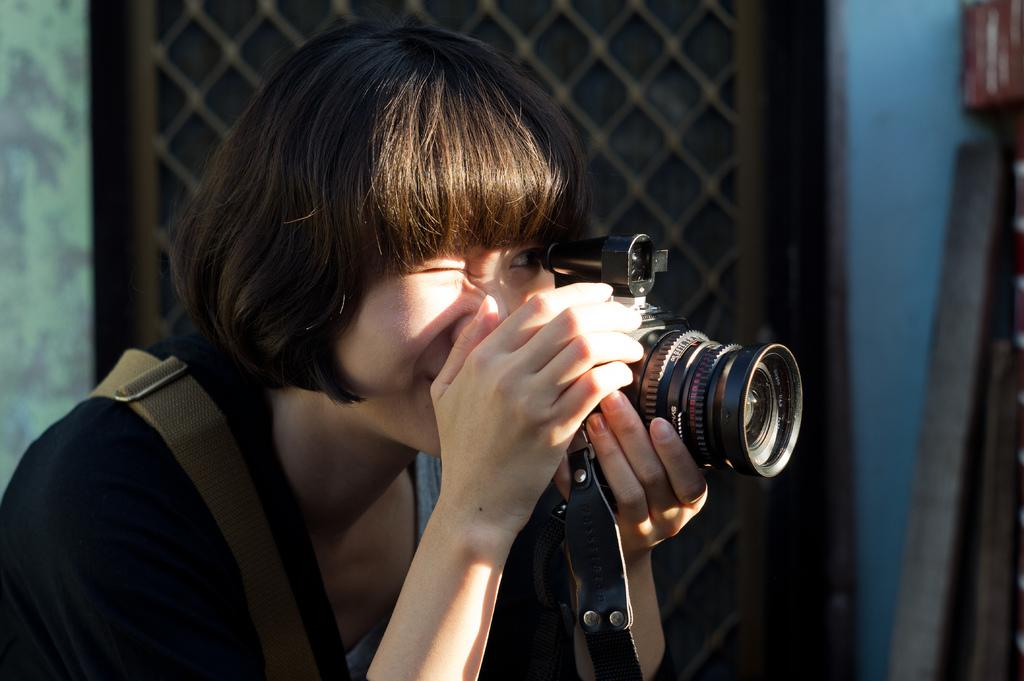Who is the main subject in the image? There is a woman in the image. What is the woman doing in the image? The woman is catching a camera. What type of lettuce is being used to push the camera in the image? There is no lettuce present in the image, nor is there any indication of the camera being pushed. 